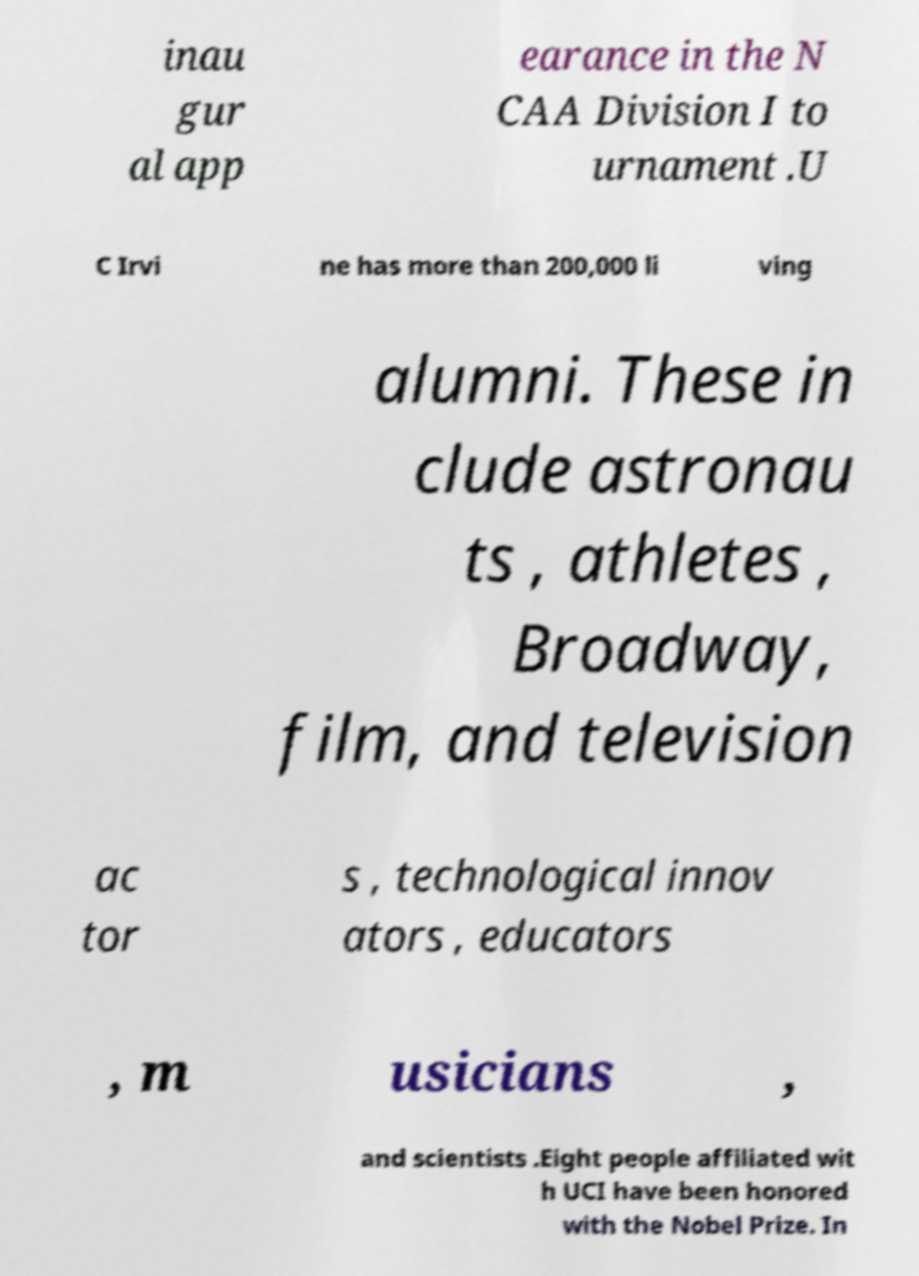Please read and relay the text visible in this image. What does it say? inau gur al app earance in the N CAA Division I to urnament .U C Irvi ne has more than 200,000 li ving alumni. These in clude astronau ts , athletes , Broadway, film, and television ac tor s , technological innov ators , educators , m usicians , and scientists .Eight people affiliated wit h UCI have been honored with the Nobel Prize. In 